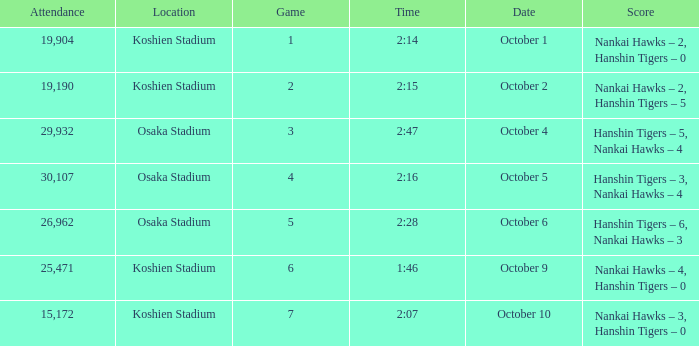How many games have an Attendance of 19,190? 1.0. 